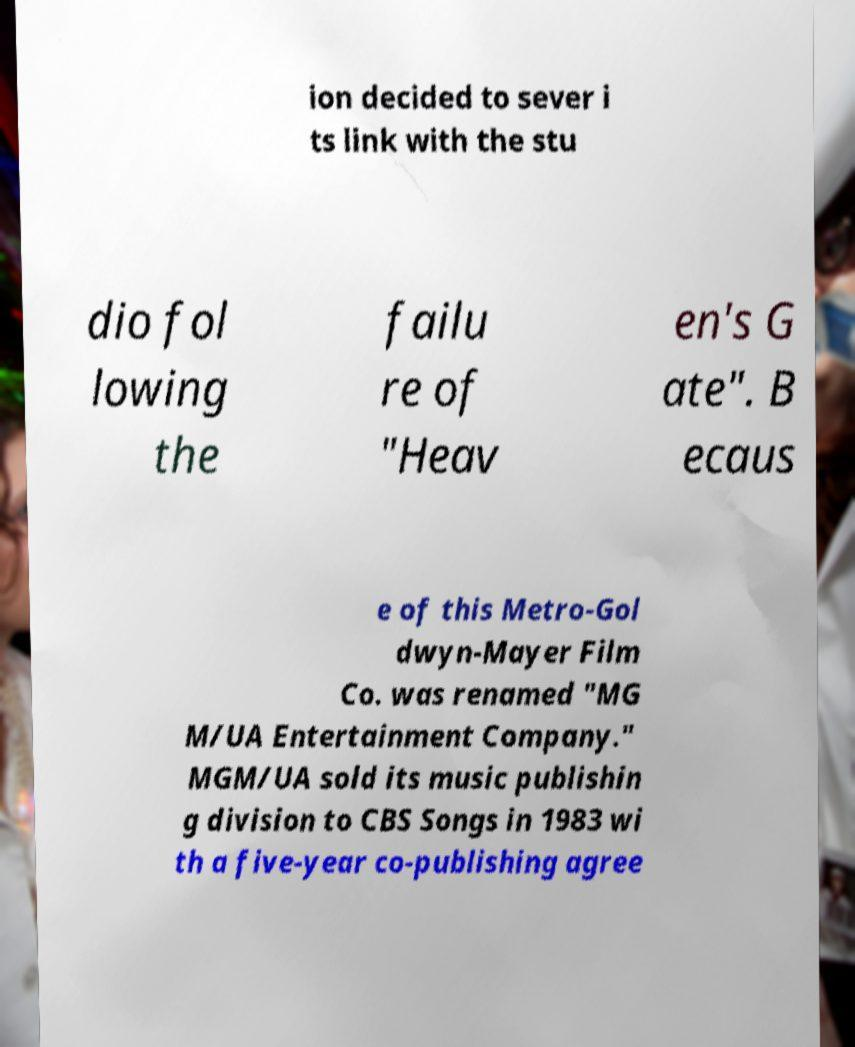Could you extract and type out the text from this image? ion decided to sever i ts link with the stu dio fol lowing the failu re of "Heav en's G ate". B ecaus e of this Metro-Gol dwyn-Mayer Film Co. was renamed "MG M/UA Entertainment Company." MGM/UA sold its music publishin g division to CBS Songs in 1983 wi th a five-year co-publishing agree 